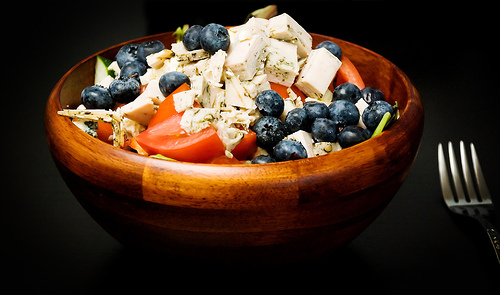<image>
Is there a food on the table? Yes. Looking at the image, I can see the food is positioned on top of the table, with the table providing support. Where is the tomatoe in relation to the blueberry? Is it in the blueberry? No. The tomatoe is not contained within the blueberry. These objects have a different spatial relationship. 